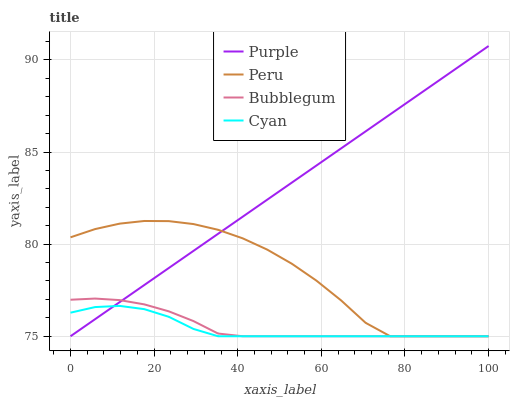Does Cyan have the minimum area under the curve?
Answer yes or no. Yes. Does Purple have the maximum area under the curve?
Answer yes or no. Yes. Does Bubblegum have the minimum area under the curve?
Answer yes or no. No. Does Bubblegum have the maximum area under the curve?
Answer yes or no. No. Is Purple the smoothest?
Answer yes or no. Yes. Is Peru the roughest?
Answer yes or no. Yes. Is Cyan the smoothest?
Answer yes or no. No. Is Cyan the roughest?
Answer yes or no. No. Does Bubblegum have the highest value?
Answer yes or no. No. 